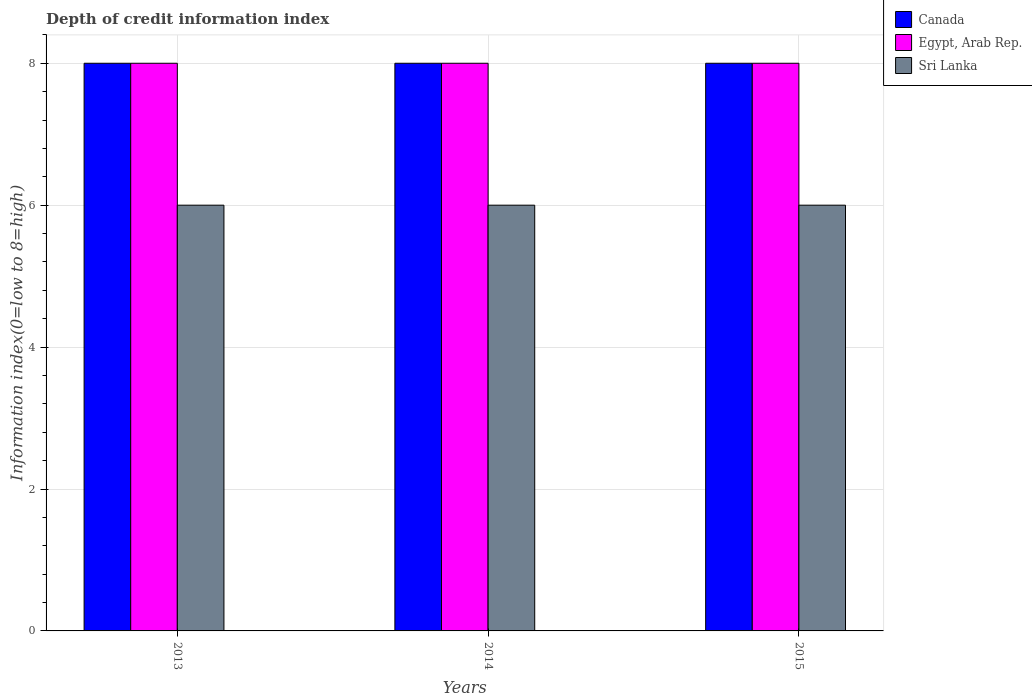How many different coloured bars are there?
Ensure brevity in your answer.  3. Are the number of bars per tick equal to the number of legend labels?
Make the answer very short. Yes. In how many cases, is the number of bars for a given year not equal to the number of legend labels?
Offer a very short reply. 0. What is the information index in Egypt, Arab Rep. in 2014?
Ensure brevity in your answer.  8. Across all years, what is the maximum information index in Canada?
Your answer should be compact. 8. Across all years, what is the minimum information index in Canada?
Offer a terse response. 8. In which year was the information index in Canada maximum?
Your answer should be very brief. 2013. In which year was the information index in Sri Lanka minimum?
Give a very brief answer. 2013. What is the total information index in Canada in the graph?
Your response must be concise. 24. What is the difference between the information index in Egypt, Arab Rep. in 2013 and that in 2014?
Provide a short and direct response. 0. What is the difference between the information index in Canada in 2015 and the information index in Egypt, Arab Rep. in 2014?
Offer a terse response. 0. What is the average information index in Sri Lanka per year?
Provide a short and direct response. 6. In the year 2014, what is the difference between the information index in Egypt, Arab Rep. and information index in Sri Lanka?
Offer a very short reply. 2. In how many years, is the information index in Sri Lanka greater than 3.2?
Your answer should be compact. 3. What is the ratio of the information index in Canada in 2013 to that in 2014?
Offer a terse response. 1. Is the information index in Canada in 2013 less than that in 2015?
Give a very brief answer. No. Is the sum of the information index in Canada in 2014 and 2015 greater than the maximum information index in Egypt, Arab Rep. across all years?
Keep it short and to the point. Yes. What does the 2nd bar from the left in 2014 represents?
Provide a short and direct response. Egypt, Arab Rep. Is it the case that in every year, the sum of the information index in Sri Lanka and information index in Canada is greater than the information index in Egypt, Arab Rep.?
Your answer should be compact. Yes. How many bars are there?
Keep it short and to the point. 9. Are all the bars in the graph horizontal?
Ensure brevity in your answer.  No. How many years are there in the graph?
Keep it short and to the point. 3. Are the values on the major ticks of Y-axis written in scientific E-notation?
Offer a terse response. No. How many legend labels are there?
Offer a very short reply. 3. How are the legend labels stacked?
Provide a short and direct response. Vertical. What is the title of the graph?
Ensure brevity in your answer.  Depth of credit information index. Does "Comoros" appear as one of the legend labels in the graph?
Provide a succinct answer. No. What is the label or title of the Y-axis?
Give a very brief answer. Information index(0=low to 8=high). What is the Information index(0=low to 8=high) in Egypt, Arab Rep. in 2013?
Ensure brevity in your answer.  8. What is the Information index(0=low to 8=high) of Canada in 2015?
Your response must be concise. 8. Across all years, what is the maximum Information index(0=low to 8=high) of Egypt, Arab Rep.?
Make the answer very short. 8. Across all years, what is the minimum Information index(0=low to 8=high) in Canada?
Ensure brevity in your answer.  8. Across all years, what is the minimum Information index(0=low to 8=high) in Egypt, Arab Rep.?
Your response must be concise. 8. What is the total Information index(0=low to 8=high) of Egypt, Arab Rep. in the graph?
Give a very brief answer. 24. What is the total Information index(0=low to 8=high) in Sri Lanka in the graph?
Your answer should be compact. 18. What is the difference between the Information index(0=low to 8=high) of Egypt, Arab Rep. in 2013 and that in 2015?
Offer a very short reply. 0. What is the difference between the Information index(0=low to 8=high) in Sri Lanka in 2013 and that in 2015?
Offer a very short reply. 0. What is the difference between the Information index(0=low to 8=high) in Egypt, Arab Rep. in 2014 and that in 2015?
Offer a terse response. 0. What is the difference between the Information index(0=low to 8=high) of Canada in 2013 and the Information index(0=low to 8=high) of Egypt, Arab Rep. in 2014?
Offer a very short reply. 0. What is the difference between the Information index(0=low to 8=high) of Canada in 2014 and the Information index(0=low to 8=high) of Egypt, Arab Rep. in 2015?
Provide a succinct answer. 0. What is the difference between the Information index(0=low to 8=high) in Canada in 2014 and the Information index(0=low to 8=high) in Sri Lanka in 2015?
Ensure brevity in your answer.  2. What is the average Information index(0=low to 8=high) in Egypt, Arab Rep. per year?
Provide a succinct answer. 8. What is the average Information index(0=low to 8=high) in Sri Lanka per year?
Your answer should be very brief. 6. In the year 2013, what is the difference between the Information index(0=low to 8=high) in Canada and Information index(0=low to 8=high) in Egypt, Arab Rep.?
Ensure brevity in your answer.  0. In the year 2013, what is the difference between the Information index(0=low to 8=high) of Canada and Information index(0=low to 8=high) of Sri Lanka?
Make the answer very short. 2. In the year 2014, what is the difference between the Information index(0=low to 8=high) in Canada and Information index(0=low to 8=high) in Egypt, Arab Rep.?
Your response must be concise. 0. In the year 2014, what is the difference between the Information index(0=low to 8=high) in Egypt, Arab Rep. and Information index(0=low to 8=high) in Sri Lanka?
Make the answer very short. 2. In the year 2015, what is the difference between the Information index(0=low to 8=high) of Canada and Information index(0=low to 8=high) of Egypt, Arab Rep.?
Your answer should be compact. 0. In the year 2015, what is the difference between the Information index(0=low to 8=high) in Egypt, Arab Rep. and Information index(0=low to 8=high) in Sri Lanka?
Provide a short and direct response. 2. What is the ratio of the Information index(0=low to 8=high) in Sri Lanka in 2013 to that in 2014?
Offer a very short reply. 1. What is the ratio of the Information index(0=low to 8=high) in Sri Lanka in 2014 to that in 2015?
Your response must be concise. 1. What is the difference between the highest and the second highest Information index(0=low to 8=high) in Canada?
Offer a terse response. 0. What is the difference between the highest and the second highest Information index(0=low to 8=high) of Sri Lanka?
Your answer should be compact. 0. What is the difference between the highest and the lowest Information index(0=low to 8=high) of Canada?
Offer a terse response. 0. What is the difference between the highest and the lowest Information index(0=low to 8=high) of Egypt, Arab Rep.?
Provide a short and direct response. 0. What is the difference between the highest and the lowest Information index(0=low to 8=high) in Sri Lanka?
Make the answer very short. 0. 